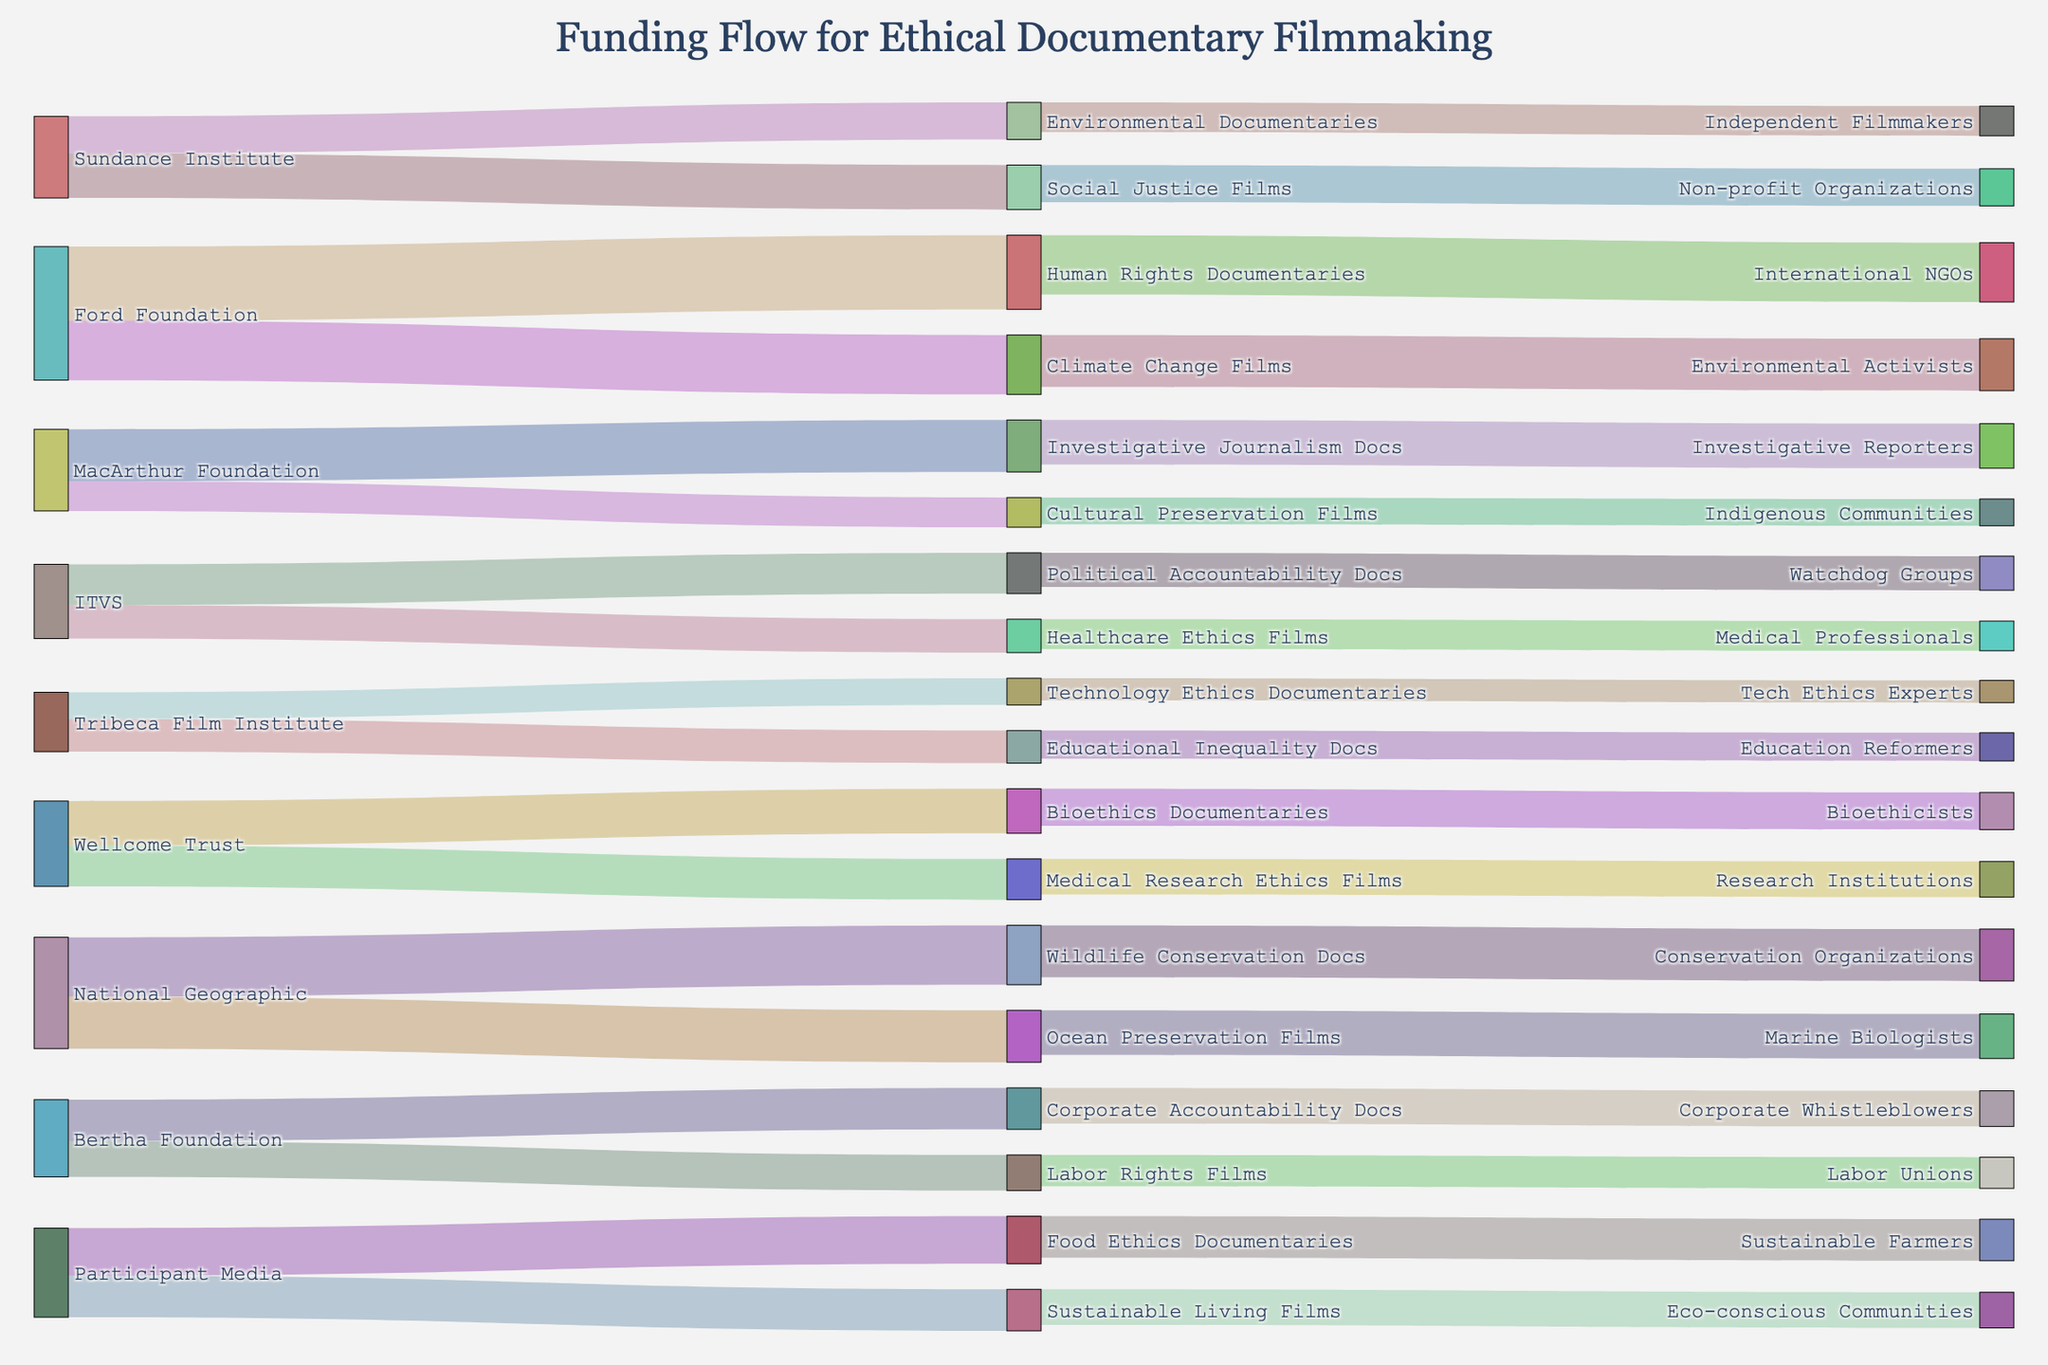what is the title of the figure? The title of the figure is typically located at the top-center of the plot, indicating the subject or focus. For this figure, it reads "Funding Flow for Ethical Documentary Filmmaking".
Answer: Funding Flow for Ethical Documentary Filmmaking How much funding did Sundance Institute allocate to Environmental Documentaries? The Sankey diagram will display flows between donors and projects. Look at the path from "Sundance Institute" to "Environmental Documentaries" to find the value.
Answer: $250,000 Which donor provided the highest amount of funding for a single type of project? Identify all donors and the specific flows to projects. Compare the values for each flow to determine the highest amount. "Ford Foundation" provided $500,000 to "Human Rights Documentaries".
Answer: Ford Foundation What is the total amount of funding received by Social Justice Films? Look for all flows going into "Social Justice Films" and sum up the values. "Social Justice Films" received $300,000 from "Sundance Institute" and $250,000 from another flow.
Answer: $550,000 Which project receives funding from both an international NGO and environmentally-related sources? Environmental-related sources could include projects like "Climate Change Films" or "Ocean Preservation Films". Cross-reference any direct flows from international NGOs.
Answer: Human Rights Documentaries What is the combined funding amount for Technology Ethics Documentaries and Bioethics Documentaries? Find the values for both "Technology Ethics Documentaries" and "Bioethics Documentaries" and add them together. "Technology Ethics Documentaries" received $180,000 from "Tribeca Film Institute" and "Bioethics Documentaries" received $300,000 from "Wellcome Trust". Adding them up gives $180,000 + $300,000.
Answer: $480,000 Which intermediary has directed funds specifically towards Indigenous Communities? Look for flows coming out of intermediaries and entering "Indigenous Communities". "MacArthur Foundation" directed funds towards "Cultural Preservation Films", which are then directed towards "Indigenous Communities".
Answer: MacArthur Foundation Compare the funding amounts for Political Accountability Docs and Corporate Accountability Docs. Which one received more funding? Identify the values associated with each flow towards "Political Accountability Docs" and "Corporate Accountability Docs". "Political Accountability Docs" received $275,000 from "ITVS" and "Corporate Accountability Docs" received $280,000 from "Bertha Foundation".
Answer: Corporate Accountability Docs How many different types of ethical documentary projects received funding? Count all unique project types listed as targets in the Sankey diagram to see how many different types received funding.
Answer: 18 What ultimately receives more funding: Investigative Reporting or Academic Research? Investigative Reporting can be represented by "Investigative Journalism Docs" and "Investigative Reporters". Academic Research could be projects involving "Bioethics", "Medical Research", etc. Sum the values for each relevant category to compare totals.
Answer: Varies by the specific categories and sums 